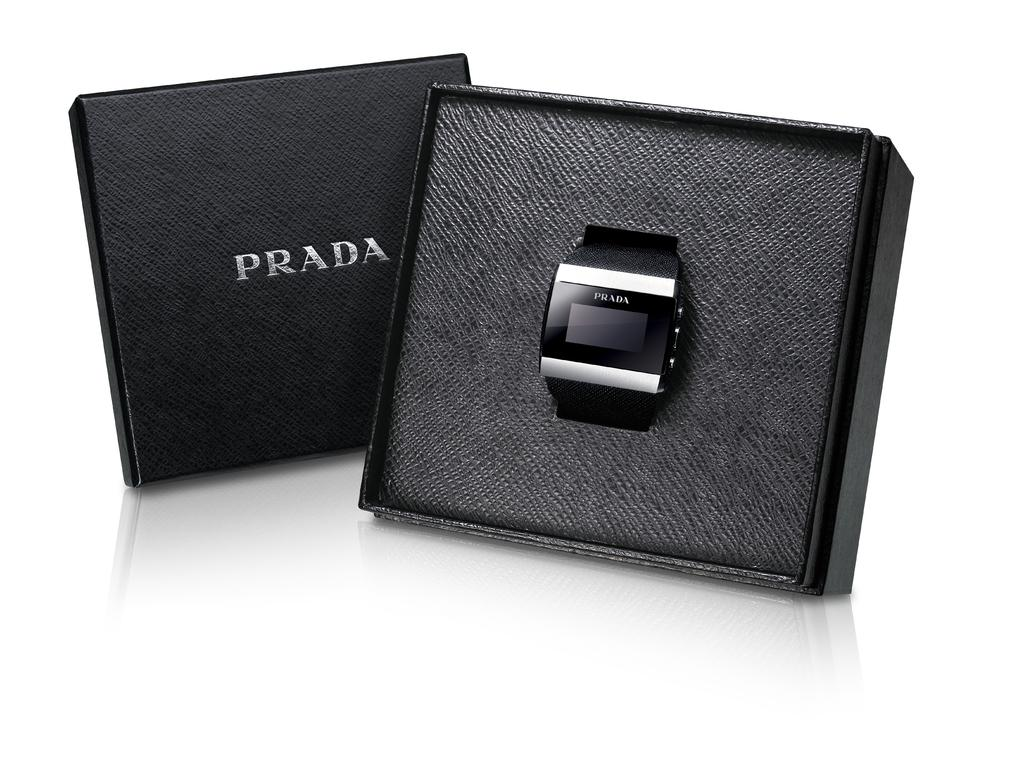<image>
Give a short and clear explanation of the subsequent image. A black Prada watch with silver trim in a black square box. 